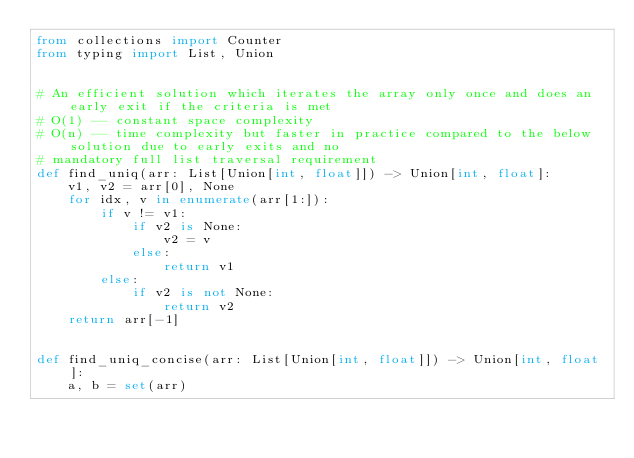Convert code to text. <code><loc_0><loc_0><loc_500><loc_500><_Python_>from collections import Counter
from typing import List, Union


# An efficient solution which iterates the array only once and does an early exit if the criteria is met
# O(1) -- constant space complexity
# O(n) -- time complexity but faster in practice compared to the below solution due to early exits and no
# mandatory full list traversal requirement
def find_uniq(arr: List[Union[int, float]]) -> Union[int, float]:
    v1, v2 = arr[0], None
    for idx, v in enumerate(arr[1:]):
        if v != v1:
            if v2 is None:
                v2 = v
            else:
                return v1
        else:
            if v2 is not None:
                return v2
    return arr[-1]


def find_uniq_concise(arr: List[Union[int, float]]) -> Union[int, float]:
    a, b = set(arr)</code> 